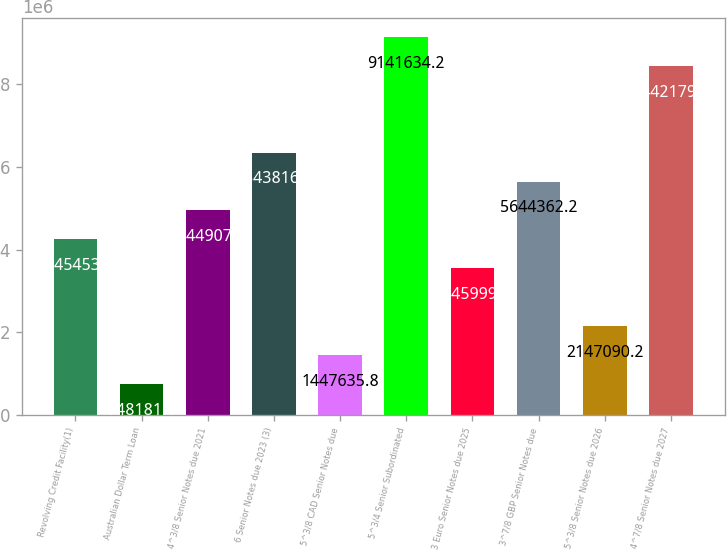<chart> <loc_0><loc_0><loc_500><loc_500><bar_chart><fcel>Revolving Credit Facility(1)<fcel>Australian Dollar Term Loan<fcel>4^3/8 Senior Notes due 2021<fcel>6 Senior Notes due 2023 (3)<fcel>5^3/8 CAD Senior Notes due<fcel>5^3/4 Senior Subordinated<fcel>3 Euro Senior Notes due 2025<fcel>3^7/8 GBP Senior Notes due<fcel>5^3/8 Senior Notes due 2026<fcel>4^7/8 Senior Notes due 2027<nl><fcel>4.24545e+06<fcel>748181<fcel>4.94491e+06<fcel>6.34382e+06<fcel>1.44764e+06<fcel>9.14163e+06<fcel>3.546e+06<fcel>5.64436e+06<fcel>2.14709e+06<fcel>8.44218e+06<nl></chart> 